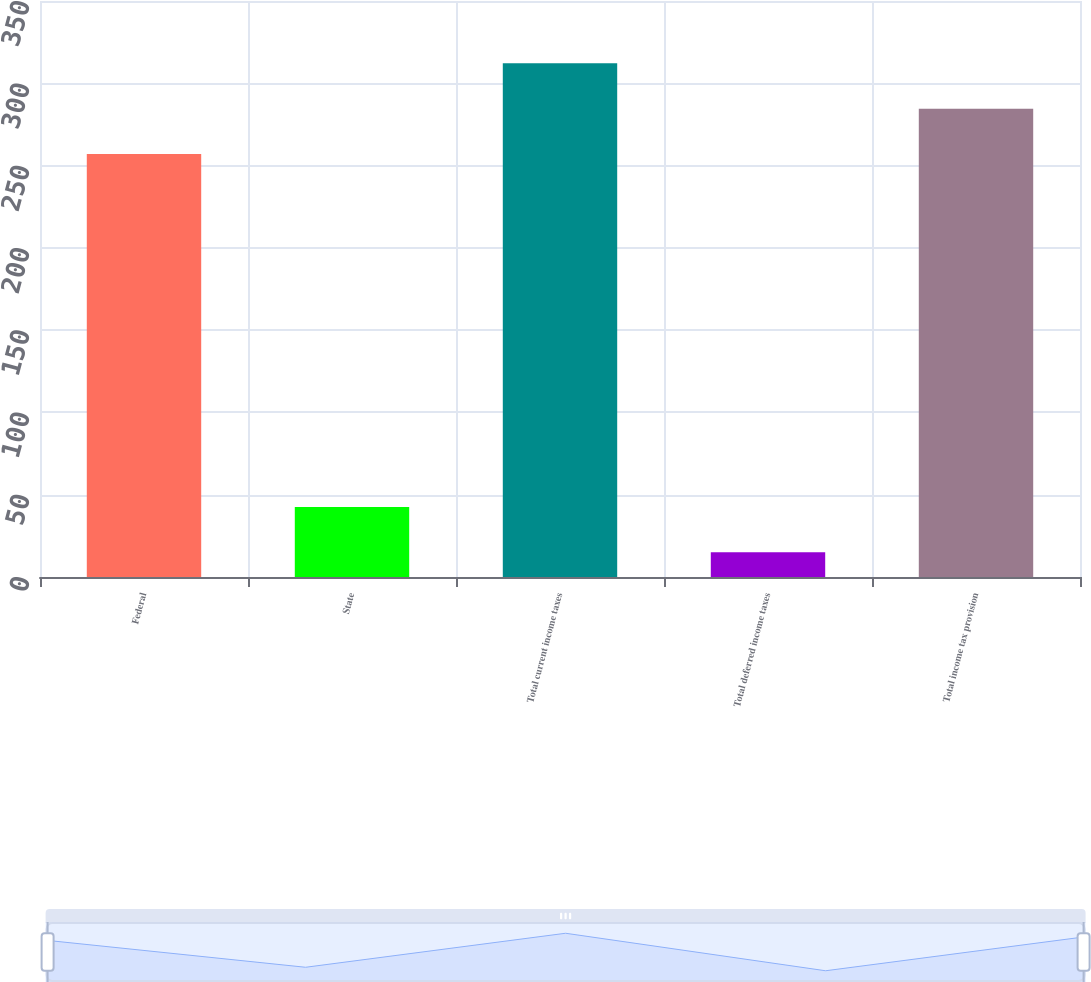Convert chart. <chart><loc_0><loc_0><loc_500><loc_500><bar_chart><fcel>Federal<fcel>State<fcel>Total current income taxes<fcel>Total deferred income taxes<fcel>Total income tax provision<nl><fcel>257<fcel>42.6<fcel>312.2<fcel>15<fcel>284.6<nl></chart> 